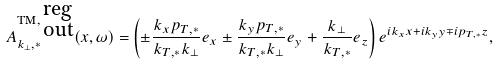Convert formula to latex. <formula><loc_0><loc_0><loc_500><loc_500>A ^ { \text {TM} , \, \substack { \text {reg} \\ \text {out} } } _ { k _ { \perp } , * } ( x , \omega ) = & \left ( \pm \frac { k _ { x } p _ { T , * } } { k _ { T , * } k _ { \perp } } e _ { x } \pm \frac { k _ { y } p _ { T , * } } { k _ { T , * } k _ { \perp } } e _ { y } + \frac { k _ { \perp } } { k _ { T , * } } e _ { z } \right ) e ^ { i k _ { x } x + i k _ { y } y \mp i p _ { T , * } z } ,</formula> 